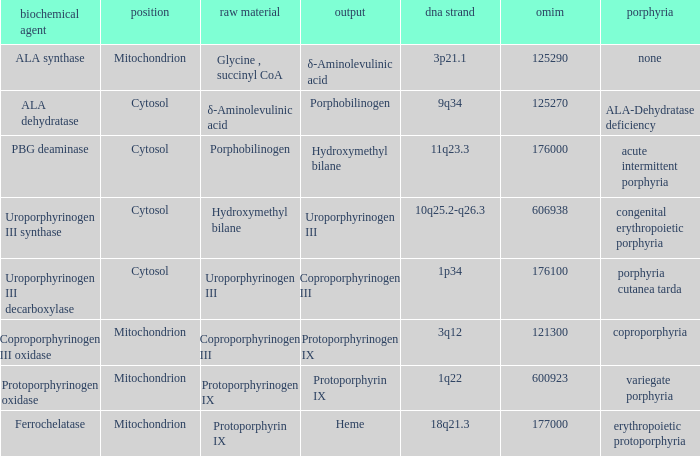Which substrate has an OMIM of 176000? Porphobilinogen. 